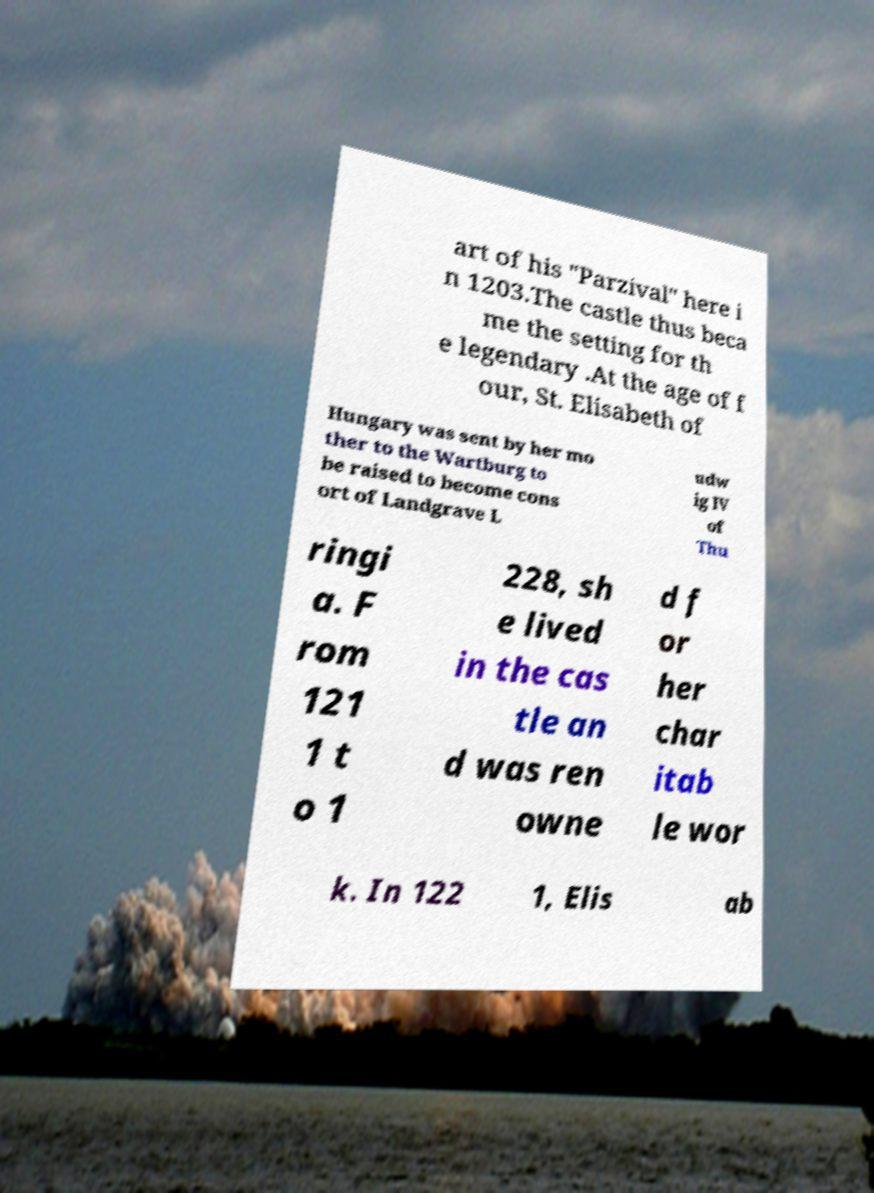There's text embedded in this image that I need extracted. Can you transcribe it verbatim? art of his "Parzival" here i n 1203.The castle thus beca me the setting for th e legendary .At the age of f our, St. Elisabeth of Hungary was sent by her mo ther to the Wartburg to be raised to become cons ort of Landgrave L udw ig IV of Thu ringi a. F rom 121 1 t o 1 228, sh e lived in the cas tle an d was ren owne d f or her char itab le wor k. In 122 1, Elis ab 